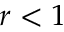Convert formula to latex. <formula><loc_0><loc_0><loc_500><loc_500>r < 1</formula> 